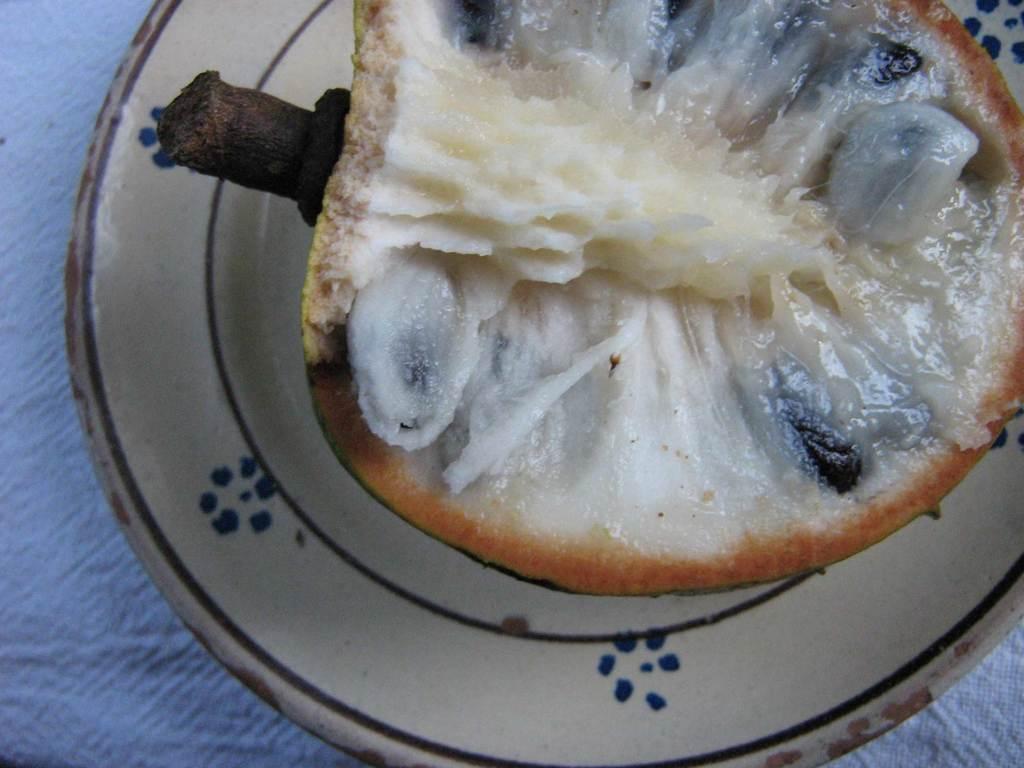In one or two sentences, can you explain what this image depicts? In this image we can see a fruit with seeds is placed on a plate. 